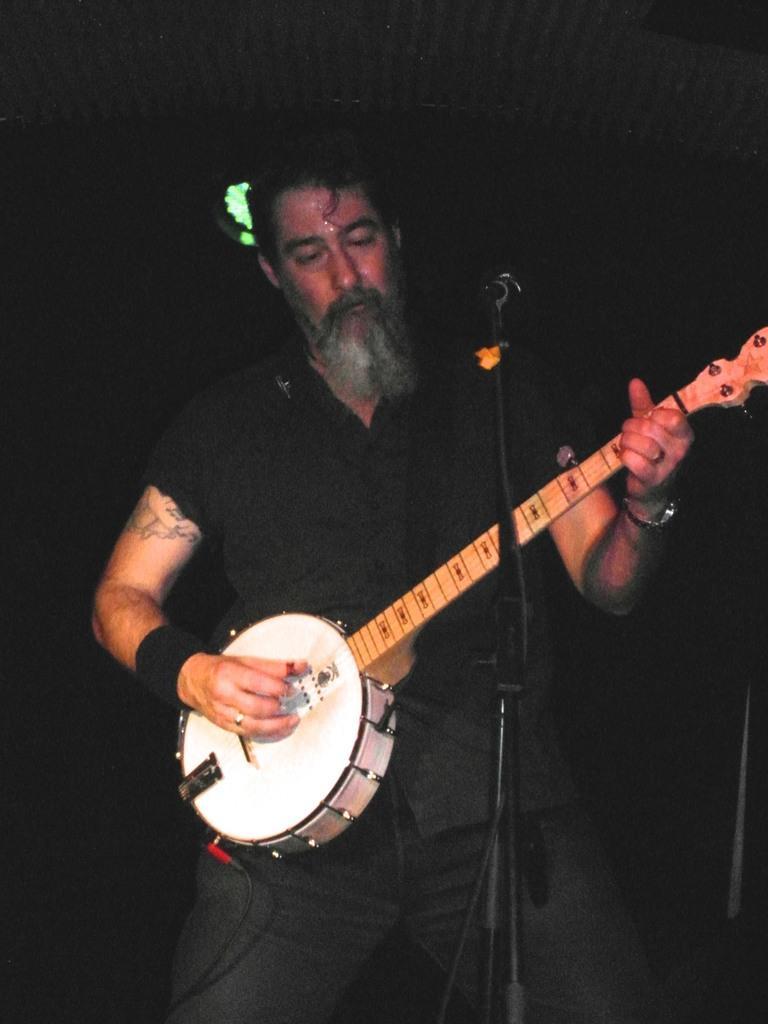What is the person in the image doing? The person is standing and playing a musical instrument. What is the person wearing? The person is wearing a black color shirt. What equipment is present in the image for amplifying sound? There is a microphone with a stand in the image. What can be seen in the background of the image? There are focusing lights in the background of the image. Can you see any sand or hens in the image? No, there is no sand or hens present in the image. Is there a volcano visible in the background of the image? No, there is no volcano visible in the image; only focusing lights are present in the background. 